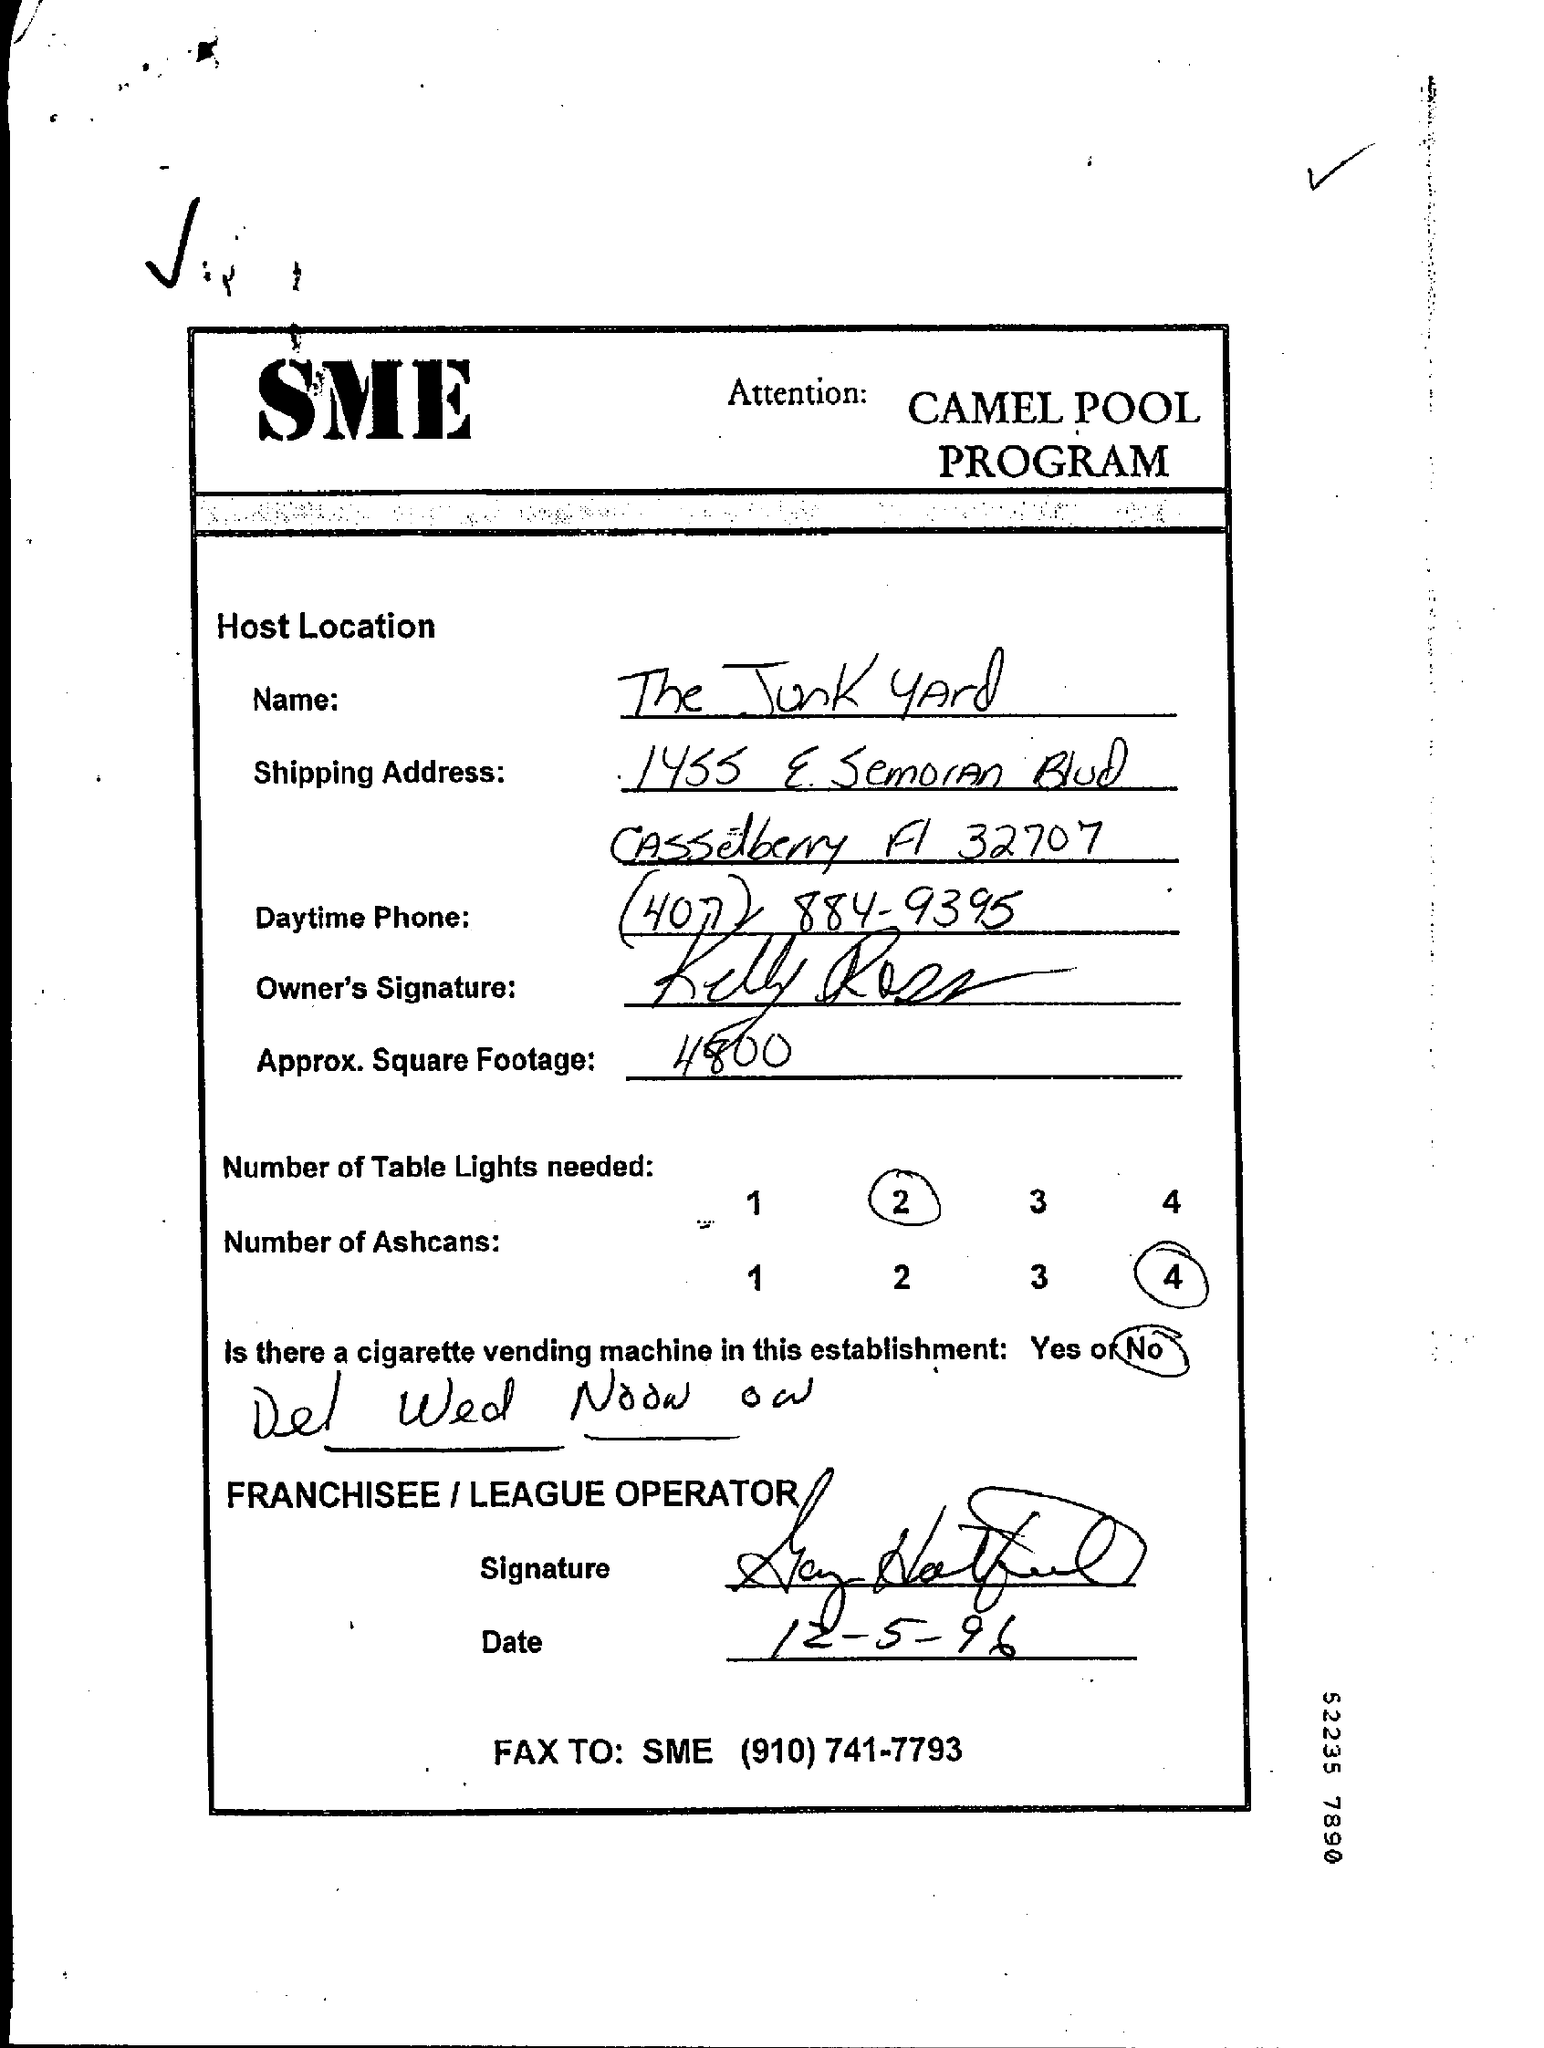Point out several critical features in this image. The date is December 5, 1996. The number of table lights required is two. The number of ashcans is 4. The approximate square footage is approximately 4800 square feet. The Host Location Name is the Junk Yard. 